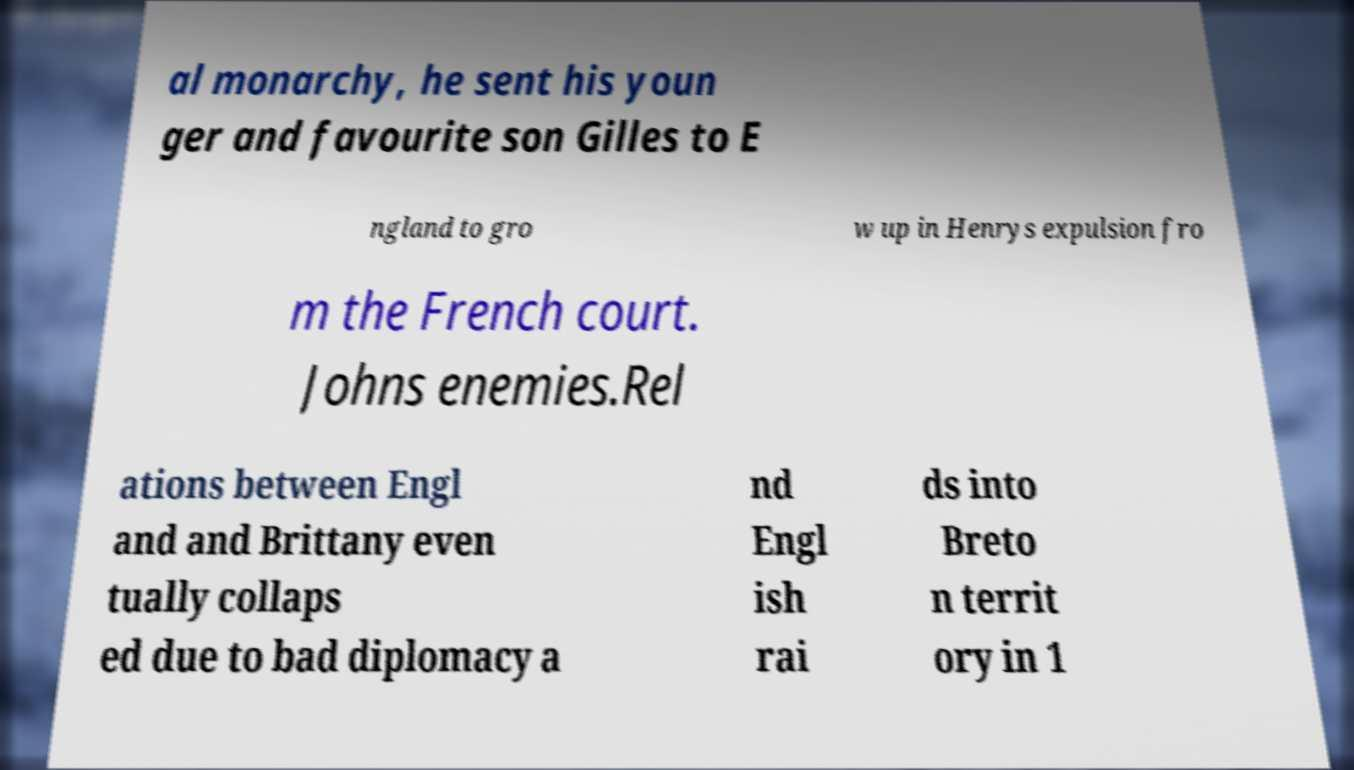Could you assist in decoding the text presented in this image and type it out clearly? al monarchy, he sent his youn ger and favourite son Gilles to E ngland to gro w up in Henrys expulsion fro m the French court. Johns enemies.Rel ations between Engl and and Brittany even tually collaps ed due to bad diplomacy a nd Engl ish rai ds into Breto n territ ory in 1 